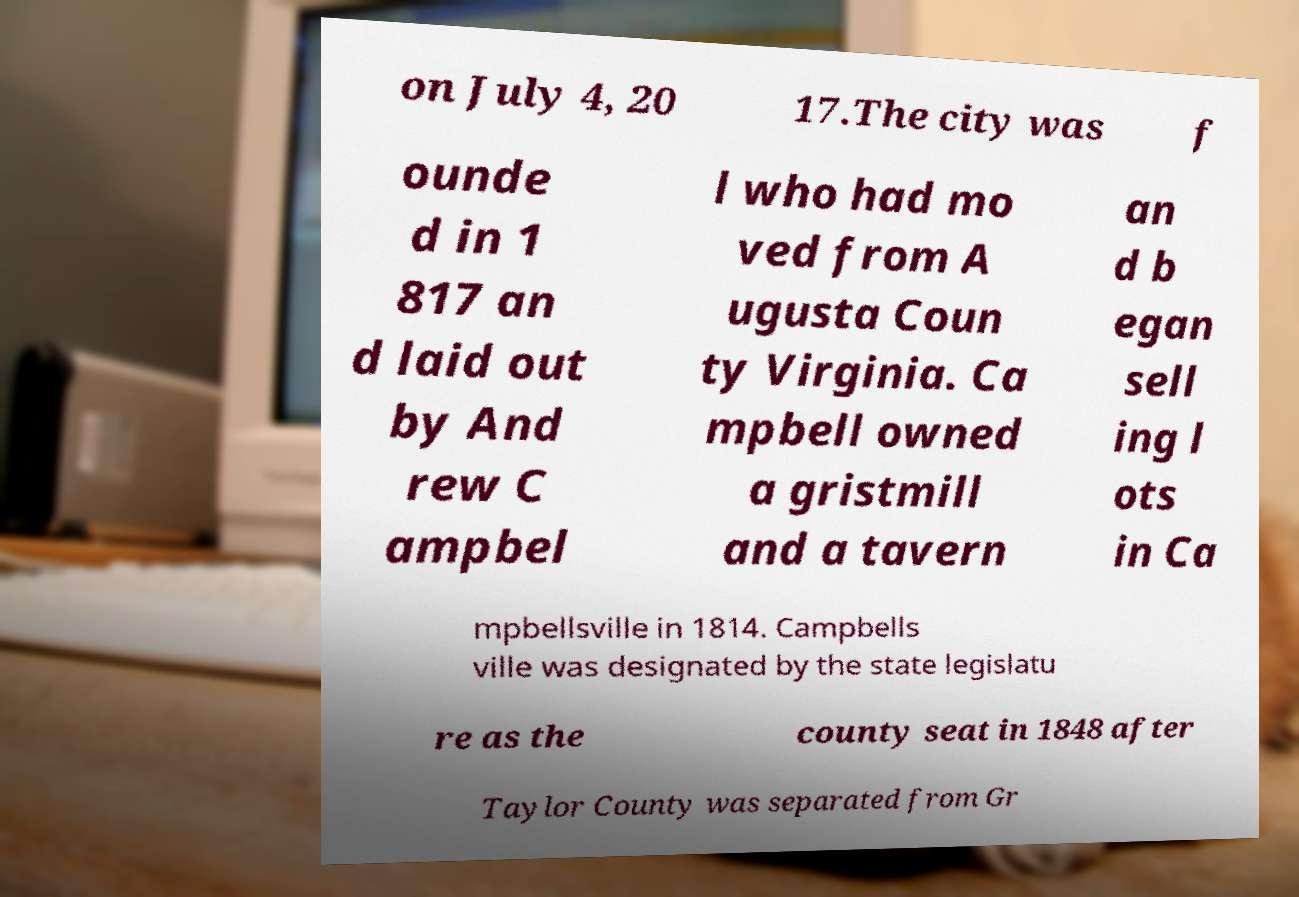Can you accurately transcribe the text from the provided image for me? on July 4, 20 17.The city was f ounde d in 1 817 an d laid out by And rew C ampbel l who had mo ved from A ugusta Coun ty Virginia. Ca mpbell owned a gristmill and a tavern an d b egan sell ing l ots in Ca mpbellsville in 1814. Campbells ville was designated by the state legislatu re as the county seat in 1848 after Taylor County was separated from Gr 